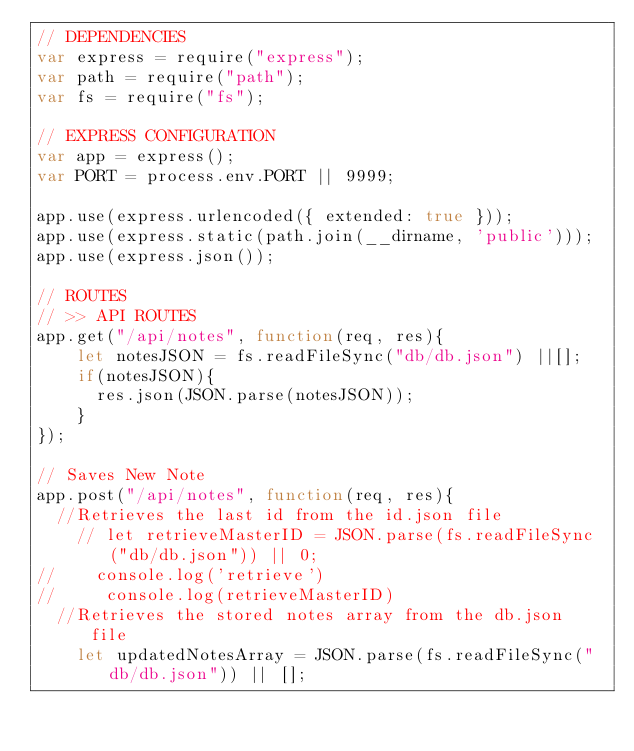<code> <loc_0><loc_0><loc_500><loc_500><_JavaScript_>// DEPENDENCIES
var express = require("express");
var path = require("path");
var fs = require("fs");

// EXPRESS CONFIGURATION
var app = express();
var PORT = process.env.PORT || 9999;

app.use(express.urlencoded({ extended: true }));
app.use(express.static(path.join(__dirname, 'public')));
app.use(express.json());

// ROUTES
// >> API ROUTES
app.get("/api/notes", function(req, res){
    let notesJSON = fs.readFileSync("db/db.json") ||[];
    if(notesJSON){
      res.json(JSON.parse(notesJSON));
    }
});

// Saves New Note
app.post("/api/notes", function(req, res){
  //Retrieves the last id from the id.json file
    // let retrieveMasterID = JSON.parse(fs.readFileSync("db/db.json")) || 0;
//    console.log('retrieve')
//     console.log(retrieveMasterID)
  //Retrieves the stored notes array from the db.json file
    let updatedNotesArray = JSON.parse(fs.readFileSync("db/db.json")) || [];</code> 